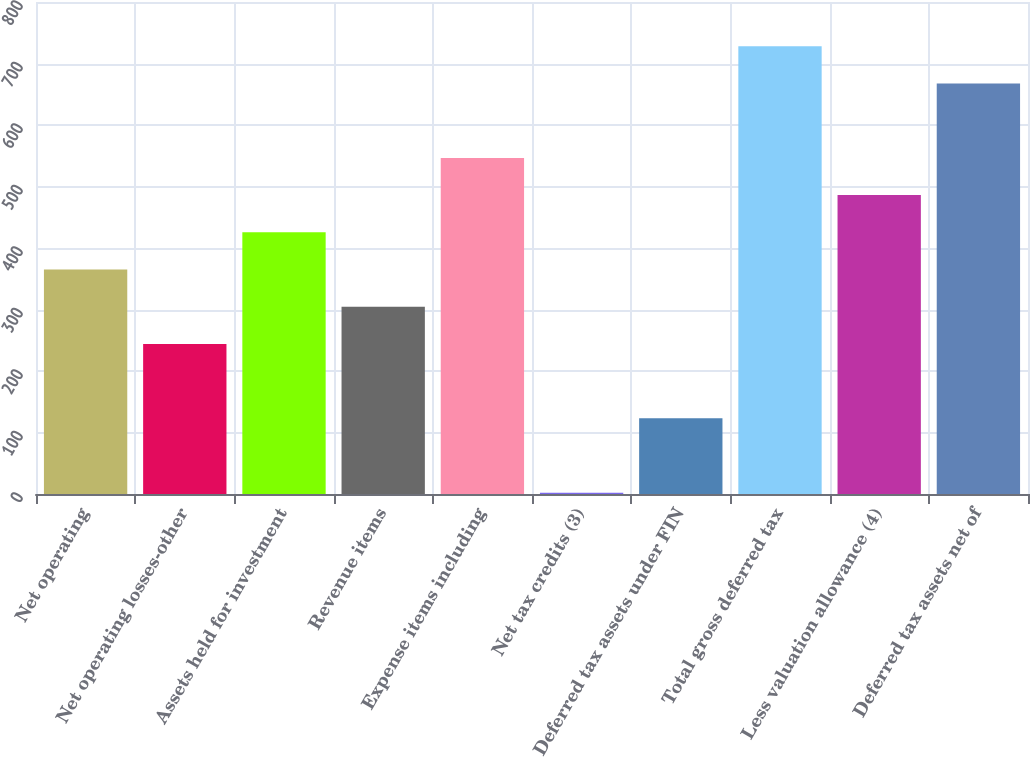<chart> <loc_0><loc_0><loc_500><loc_500><bar_chart><fcel>Net operating<fcel>Net operating losses-other<fcel>Assets held for investment<fcel>Revenue items<fcel>Expense items including<fcel>Net tax credits (3)<fcel>Deferred tax assets under FIN<fcel>Total gross deferred tax<fcel>Less valuation allowance (4)<fcel>Deferred tax assets net of<nl><fcel>365<fcel>244<fcel>425.5<fcel>304.5<fcel>546.5<fcel>2<fcel>123<fcel>728<fcel>486<fcel>667.5<nl></chart> 